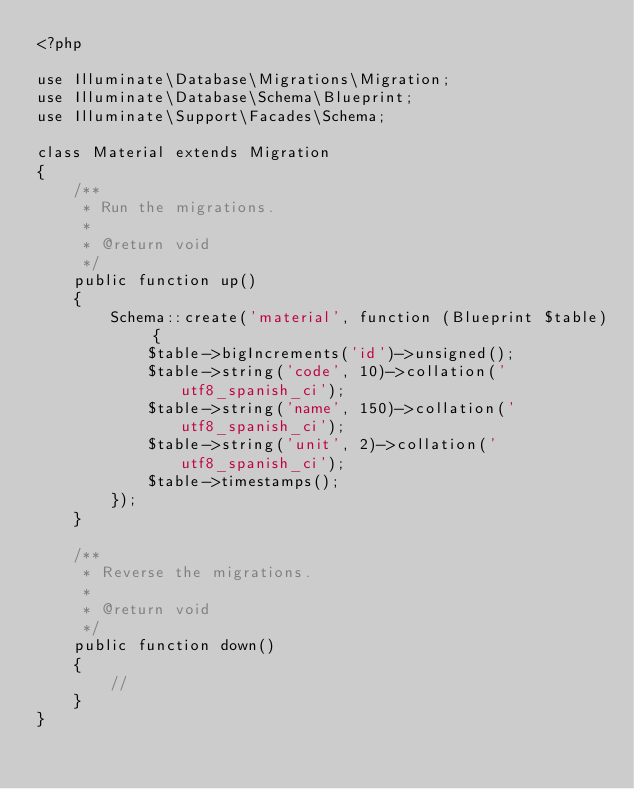<code> <loc_0><loc_0><loc_500><loc_500><_PHP_><?php

use Illuminate\Database\Migrations\Migration;
use Illuminate\Database\Schema\Blueprint;
use Illuminate\Support\Facades\Schema;

class Material extends Migration
{
    /**
     * Run the migrations.
     *
     * @return void
     */
    public function up()
    {
        Schema::create('material', function (Blueprint $table) {
            $table->bigIncrements('id')->unsigned();
            $table->string('code', 10)->collation('utf8_spanish_ci');
            $table->string('name', 150)->collation('utf8_spanish_ci');
            $table->string('unit', 2)->collation('utf8_spanish_ci');    
            $table->timestamps();   
        });
    }

    /**
     * Reverse the migrations.
     *
     * @return void
     */
    public function down()
    {
        //
    }
}
</code> 